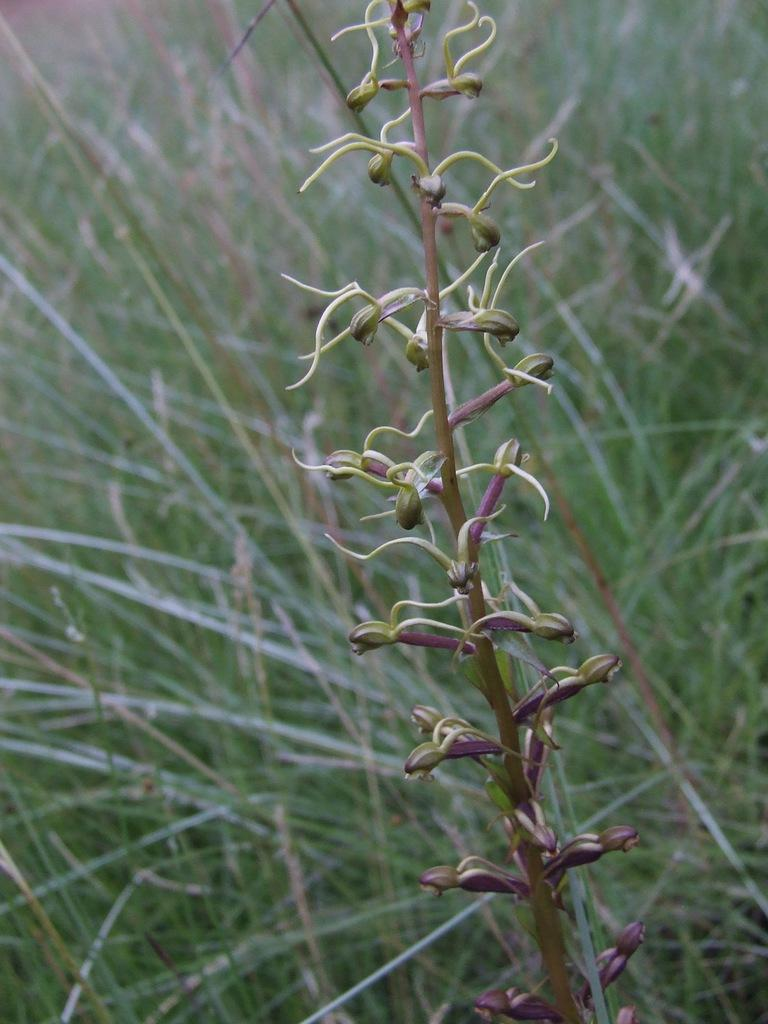What is the main subject of the image? The main subject of the image is a plant with flower buds. Can you describe the plant's surroundings? There is grass visible in the background of the image. What is the title of the book that the plant is reading in the image? There is no book or reading activity depicted in the image; it features a plant with flower buds and grass in the background. 